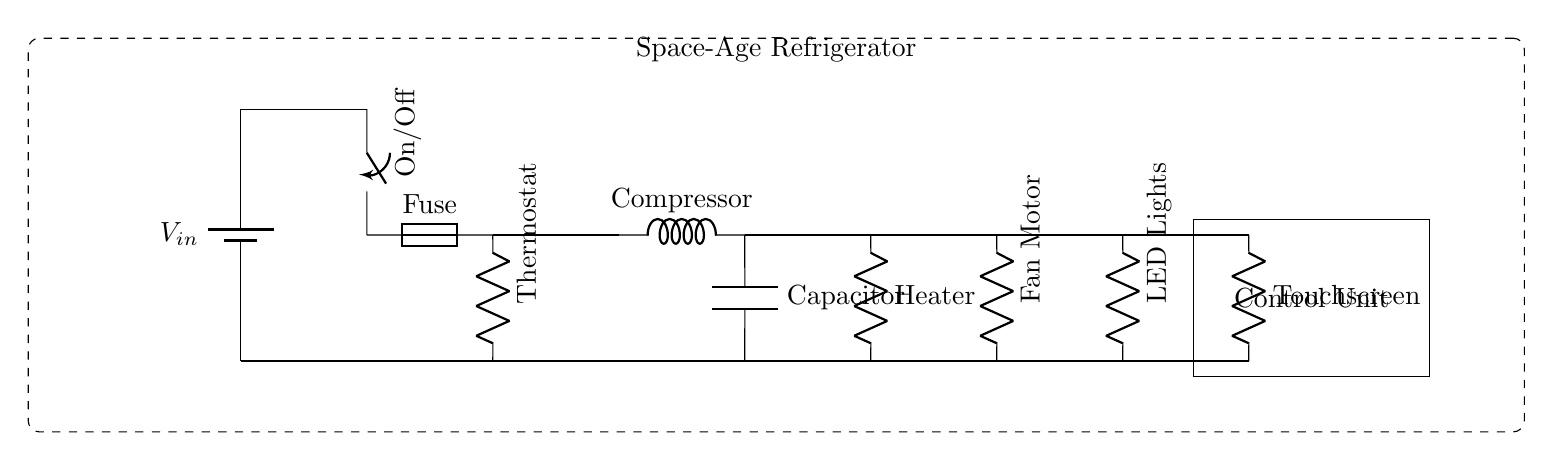What is the main power source for this refrigerator circuit? The main power source is represented by the battery symbol labeled V in the top left corner of the circuit, which provides the necessary voltage for operation.
Answer: battery What component controls the cooling and heating function? The thermostat, labeled in the circuit, is the component responsible for regulating the temperature, turning the compressor and heater on or off as needed.
Answer: Thermostat How many resistive components are in the circuit? There are three resistive components labeled as Heater, Fan Motor, and LED Lights, which indicates that there are three resistors in total found in the circuit.
Answer: three What type of device is represented by the component connected to the touchscreen? The component connected to the touchscreen is the Control Unit, which processes and manages the input from the touchscreen and operates the other components accordingly.
Answer: Control Unit Which component is responsible for the refrigeration cycle in the circuit? The compressor, indicated by the inductor symbol, is the critical component in the refrigeration cycle, as it compresses refrigerant to remove heat from the interior of the refrigerator.
Answer: Compressor How is the energy-efficient feature represented in this circuit? The energy-efficient feature is not explicitly labeled, but it can be inferred from the inclusion of components like the thermostat, which optimally controls energy usage based on temperature needs, and other efficient electronic components.
Answer: Thermostat What is the purpose of the fuse in this circuit? The fuse provides protection by interrupting the circuit in case of an overload or short circuit, preventing damage to other components such as the compressor and control unit.
Answer: Protection 